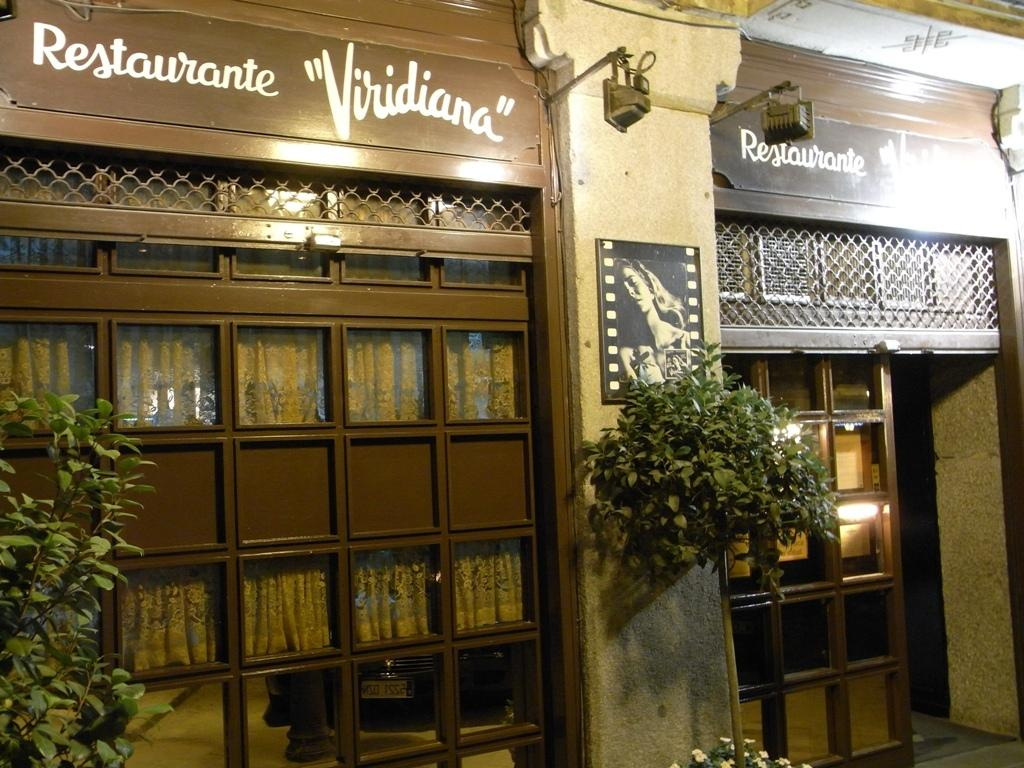<image>
Summarize the visual content of the image. Room with a sign that says Restaurante Viridiana on the top. 